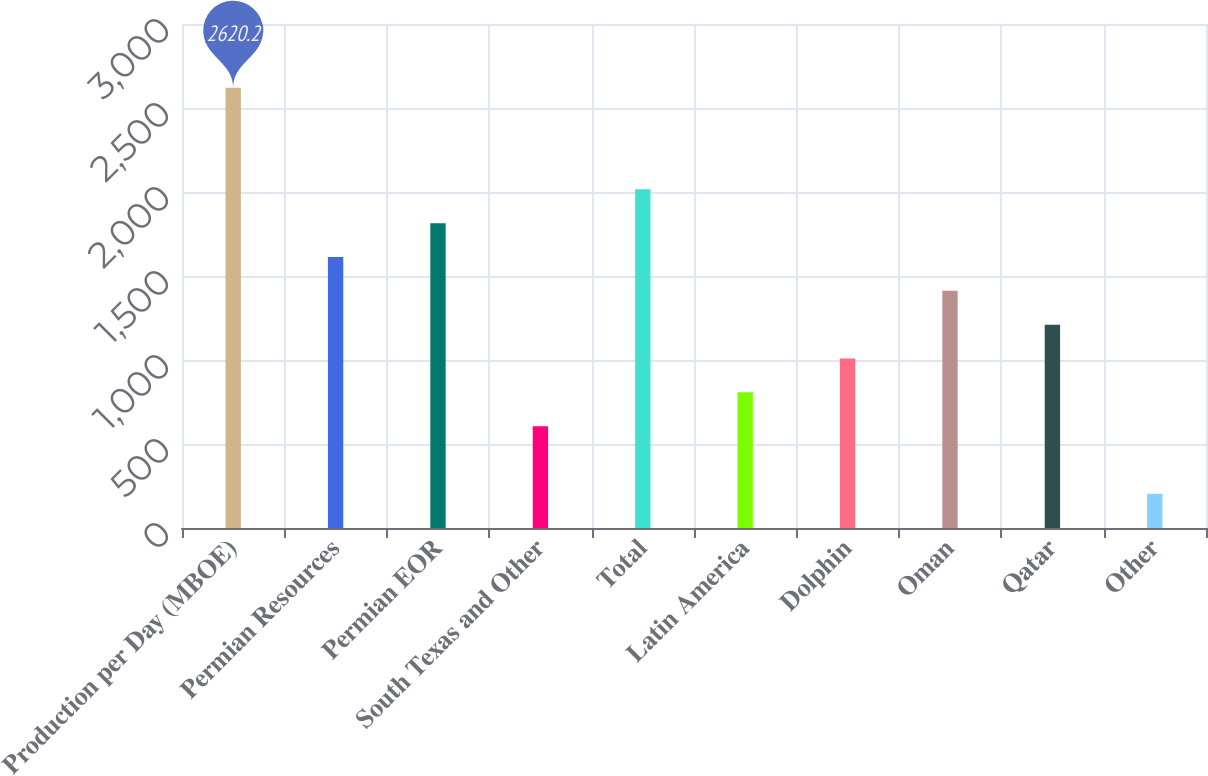Convert chart to OTSL. <chart><loc_0><loc_0><loc_500><loc_500><bar_chart><fcel>Production per Day (MBOE)<fcel>Permian Resources<fcel>Permian EOR<fcel>South Texas and Other<fcel>Total<fcel>Latin America<fcel>Dolphin<fcel>Oman<fcel>Qatar<fcel>Other<nl><fcel>2620.2<fcel>1613.2<fcel>1814.6<fcel>606.2<fcel>2016<fcel>807.6<fcel>1009<fcel>1411.8<fcel>1210.4<fcel>203.4<nl></chart> 